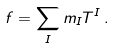<formula> <loc_0><loc_0><loc_500><loc_500>f = \sum _ { I } m _ { I } T ^ { I } \, .</formula> 